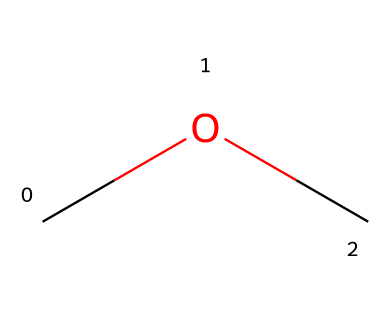What is the name of the chemical represented by the SMILES notation "COC"? The SMILES notation "COC" corresponds to a molecule with the structure consisting of two methyl groups (indicated by "C") connected to an oxygen atom ("O"). This structure is characteristic of dimethyl ether.
Answer: dimethyl ether How many carbon atoms are present in dimethyl ether? The structural representation "COC" shows two "C" atoms, indicating there are 2 carbon atoms in dimethyl ether.
Answer: 2 What type of chemical bond connects the carbon atoms to the oxygen atom in dimethyl ether? The carbon atoms are connected to the oxygen atom through single covalent bonds, as indicated by the lack of any double or triple bond notation in the SMILES "COC".
Answer: single bonds Is dimethyl ether a polar or nonpolar molecule? The presence of the oxygen atom creates a polar bond with carbon; however, the symmetrical arrangement of the molecule leads to nonpolarity overall, as the dipoles cancel out.
Answer: nonpolar What functional group is present in dimethyl ether? Dimethyl ether contains an ether functional group characterized by the R-O-R structure, where R is a hydrocarbon group (in this case, methyl groups).
Answer: ether How many hydrogen atoms are in dimethyl ether? Each methyl group contributes three hydrogen atoms, and there are two methyl groups; thus, there are a total of 6 hydrogen atoms in dimethyl ether (3 from each of the 2 methyl groups).
Answer: 6 